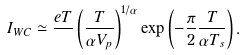<formula> <loc_0><loc_0><loc_500><loc_500>I _ { W C } \simeq \frac { e T } { } \left ( \frac { T } { \alpha V _ { p } } \right ) ^ { 1 / \alpha } \exp \left ( - \frac { \pi } { 2 } \frac { T } { \alpha T _ { s } } \right ) .</formula> 